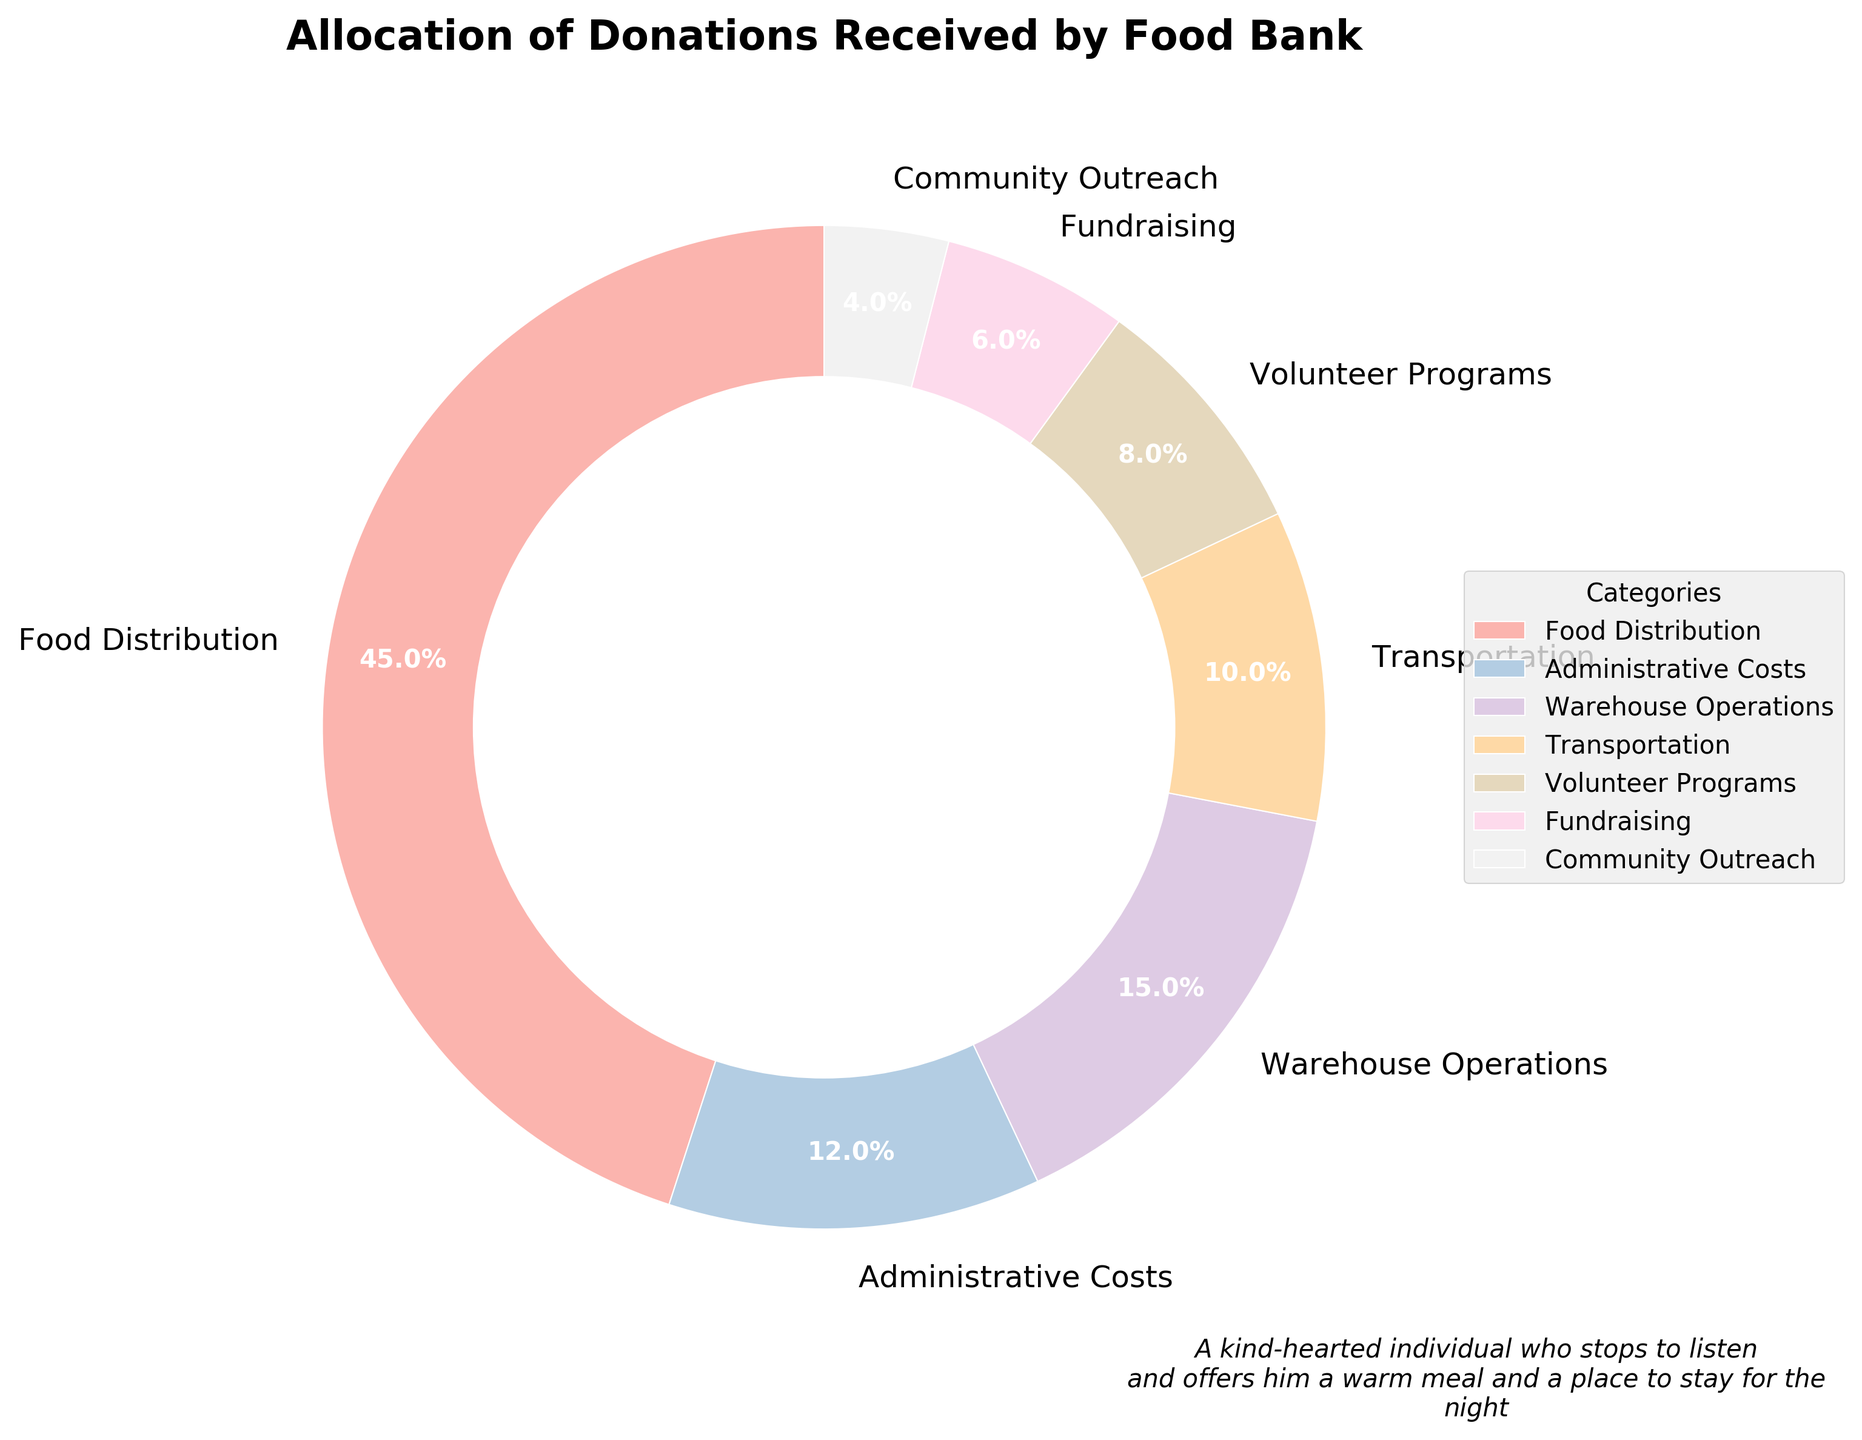Which category receives the highest percentage of donations? By inspecting the pie chart, we can see that "Food Distribution" has the largest wedge and the label confirms it has the highest percentage.
Answer: Food Distribution What is the combined percentage for Administrative Costs and Transportation? According to the pie chart, Administrative Costs take up 12% and Transportation takes up 10%. Adding these percentages together gives 12% + 10% = 22%.
Answer: 22% Which categories receive less than 10% of the donations? Looking at the pie chart, the categories with percentages less than 10% are Volunteer Programs (8%), Fundraising (6%), and Community Outreach (4%).
Answer: Volunteer Programs, Fundraising, Community Outreach How much larger is the percentage allocated to Food Distribution compared to Warehouse Operations? The percentage for Food Distribution is 45% while Warehouse Operations is 15%. The difference between these percentages is 45% - 15% = 30%.
Answer: 30% What is the total percentage allocated to categories that are not Adminstrative Costs, Warehouse Operations or Transportation? To find this, we sum the percentages for Food Distribution (45%), Volunteer Programs (8%), Fundraising (6%), and Community Outreach (4%). So, 45% + 8% + 6% + 4% = 63%.
Answer: 63% Do Fundraising and Community Outreach together receive a higher percentage than Warehouse Operations? Fundraising has 6% and Community Outreach has 4%, which sums up to 6% + 4% = 10%. Warehouse Operations has 15%. Thus, 10% is less than 15%.
Answer: No Which category has the smallest allocation and what is that percentage? The pie chart shows Community Outreach with the smallest wedge, and the label indicates it receives 4% of the donations.
Answer: Community Outreach, 4% Comparing Food Distribution and Volunteer Programs, how many times larger is the percentage for Food Distribution? The percentage for Food Distribution is 45% and for Volunteer Programs is 8%. Dividing these percentages, we get 45% / 8% = 5.625, or approximately 5.63 times larger.
Answer: About 5.63 times larger What percentage is spent on Transportation and Volunteer Programs combined? The pie chart shows Transportation at 10% and Volunteer Programs at 8%. Adding these together gives 10% + 8% = 18%.
Answer: 18% If 1000 units of donations are received, how many units are allocated to Administrative Costs? Administrative Costs take up 12% of the total donations. Therefore, 12% of 1000 units is calculated as 0.12 * 1000 = 120 units.
Answer: 120 units 